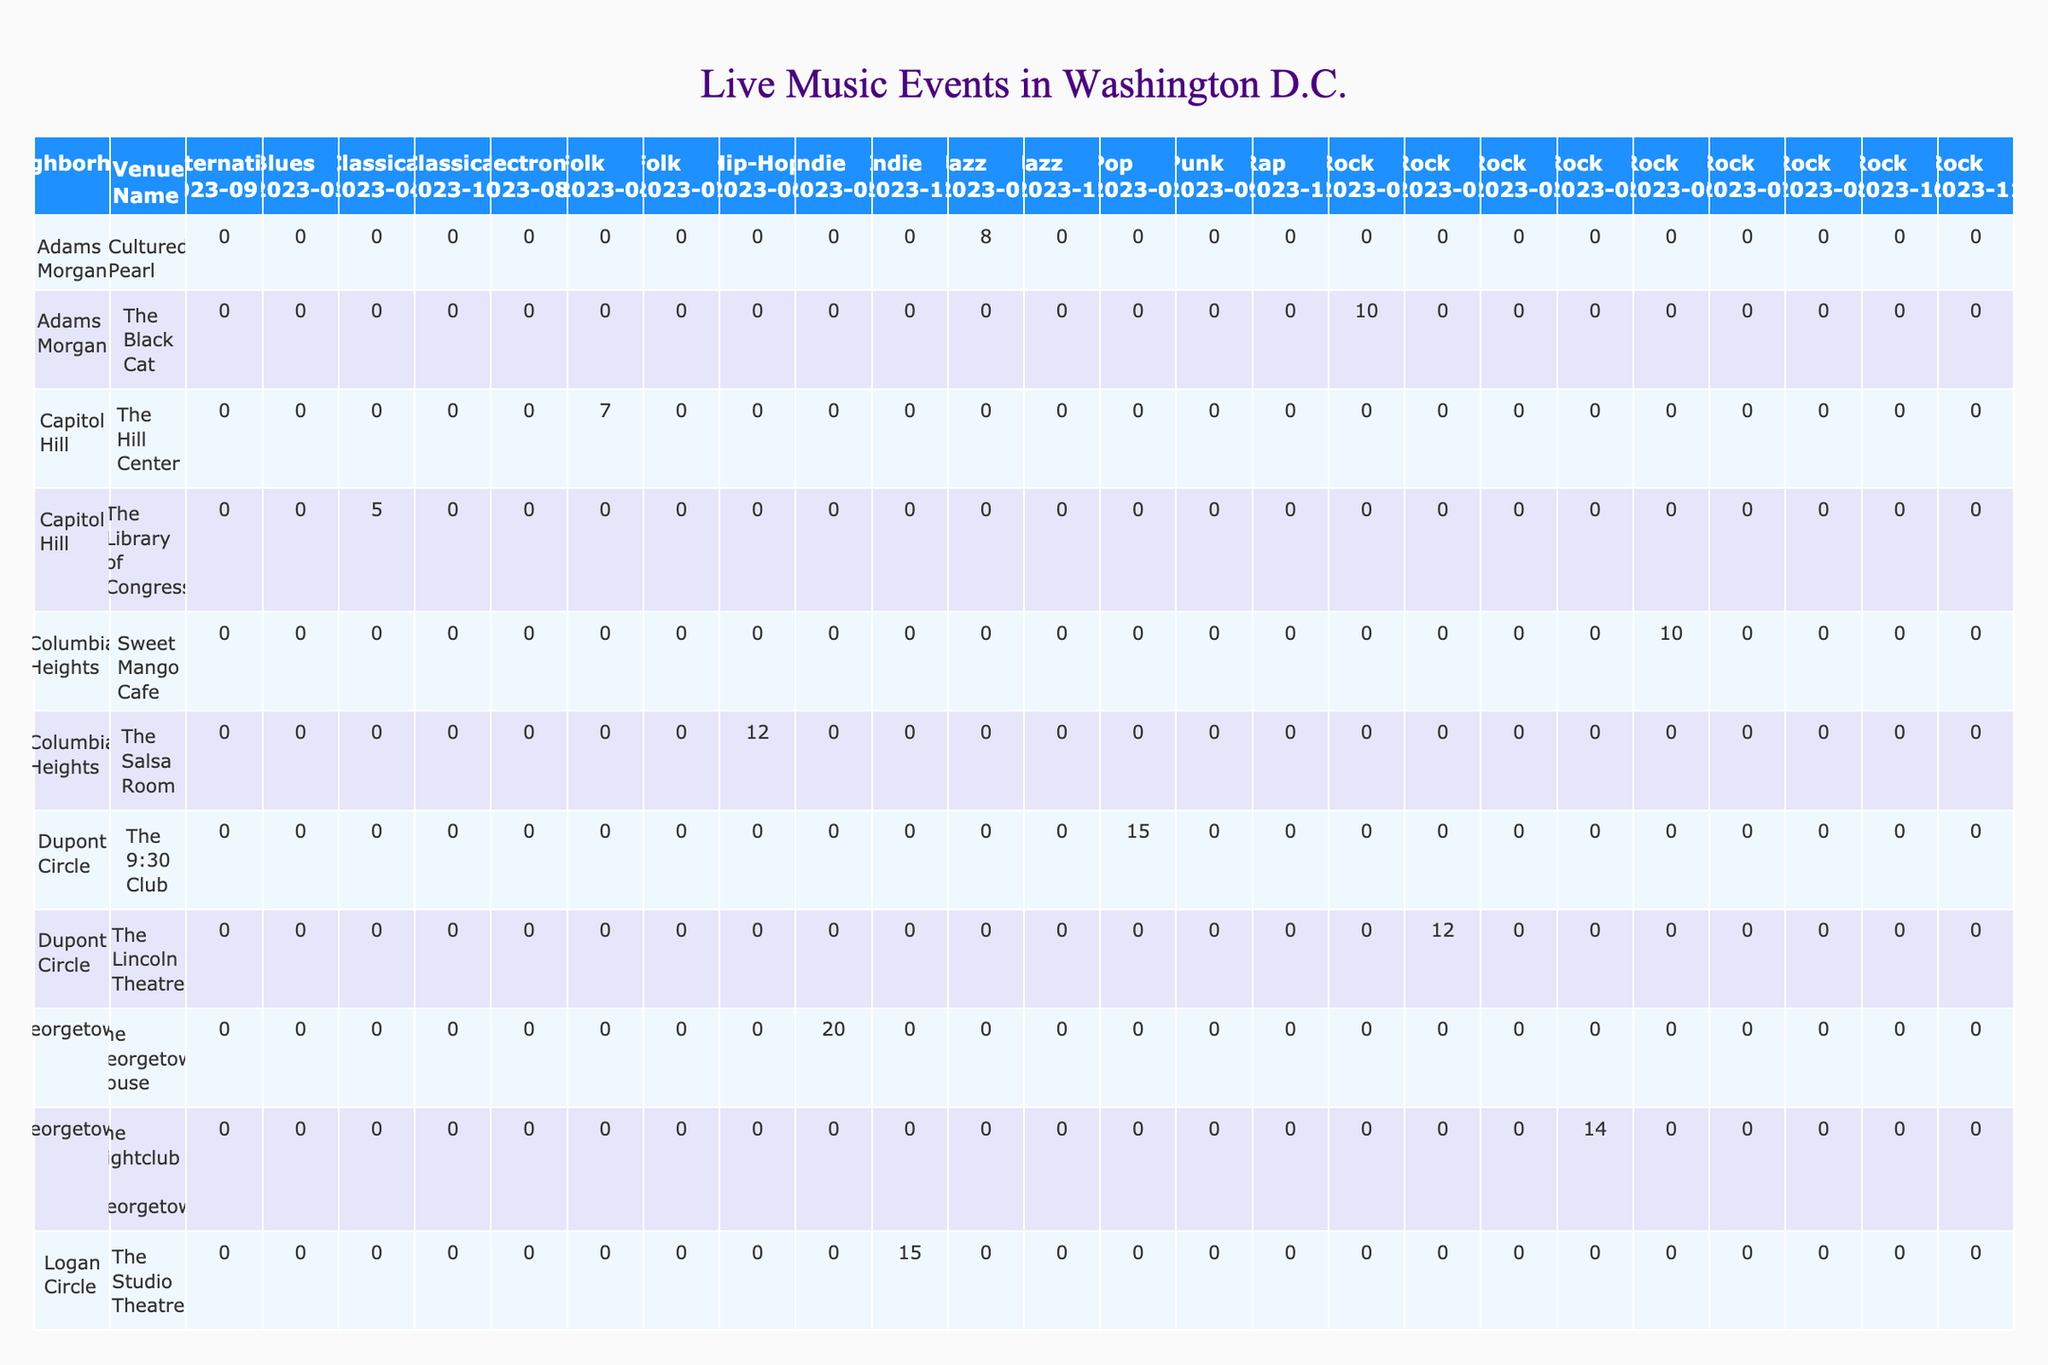How many rock events were held in Adams Morgan? The table shows that there were 10 rock events in January 2023 at The Black Cat, but no other rock events are listed in Adams Morgan for the rest of the year. Thus, the total count is just from that month.
Answer: 10 What is the total number of jazz events in Dupont Circle and West End combined? In Dupont Circle, there are no jazz events listed. However, in West End, there are 10 jazz events in November. Adding these together gives 0 + 10 = 10.
Answer: 10 Which neighborhood hosted the most rock events in total? By examining the table, we find that Adams Morgan has 10, Dupont Circle has 12, U Street has 11, Shaw has 13, Navy Yard has 9, Woodley Park has 12, and West End has 8. Shaw has the highest count with 13 rock events.
Answer: Shaw Is there any neighborhood with a genre that held fewer than 5 events? In the table, Woodley Park has a classical event with only 4 occurrences. Since it is less than 5, the answer is yes.
Answer: Yes What was the average number of live music events in Georgetown across all genres? Georgetown hosted 20 indie events and 14 rock events in May. Summing these gives 20 + 14 = 34. There are 2 events (genres) in total, so the average would be 34 / 2 = 17.
Answer: 17 Which venue in Columbia Heights hosted the most live music events? In Columbia Heights, the Salsa Room hosted 12 hip-hop events, and Sweet Mango Cafe hosted 10 rock events. The Salsa Room has the higher number at 12 events.
Answer: The Salsa Room What is the difference in the number of electronic events between Navy Yard and classical events in Woodley Park? Navy Yard had 10 electronic events in August, while Woodley Park had 4 classical events in October. Therefore, the difference is 10 - 4 = 6.
Answer: 6 Did Dupont Circle have more total pop events or more total events in all other genres combined? Dupont Circle had 15 pop events and a total of 12 rock events in February. Summing the rock events gives just 12, which is less than the pop events total. Hence, it had more pop events.
Answer: Yes Which neighborhood had the highest number of live music events in June? Columbia Heights hosted 12 hip-hop and 10 rock events in June, totaling 22 events. This is the highest count for June compared to other neighborhoods' totals that month.
Answer: Columbia Heights How many more rock events were recorded in Shaw compared to Navy Yard? Shaw had 13 rock events while Navy Yard had 9 rock events. The difference is 13 - 9 = 4.
Answer: 4 